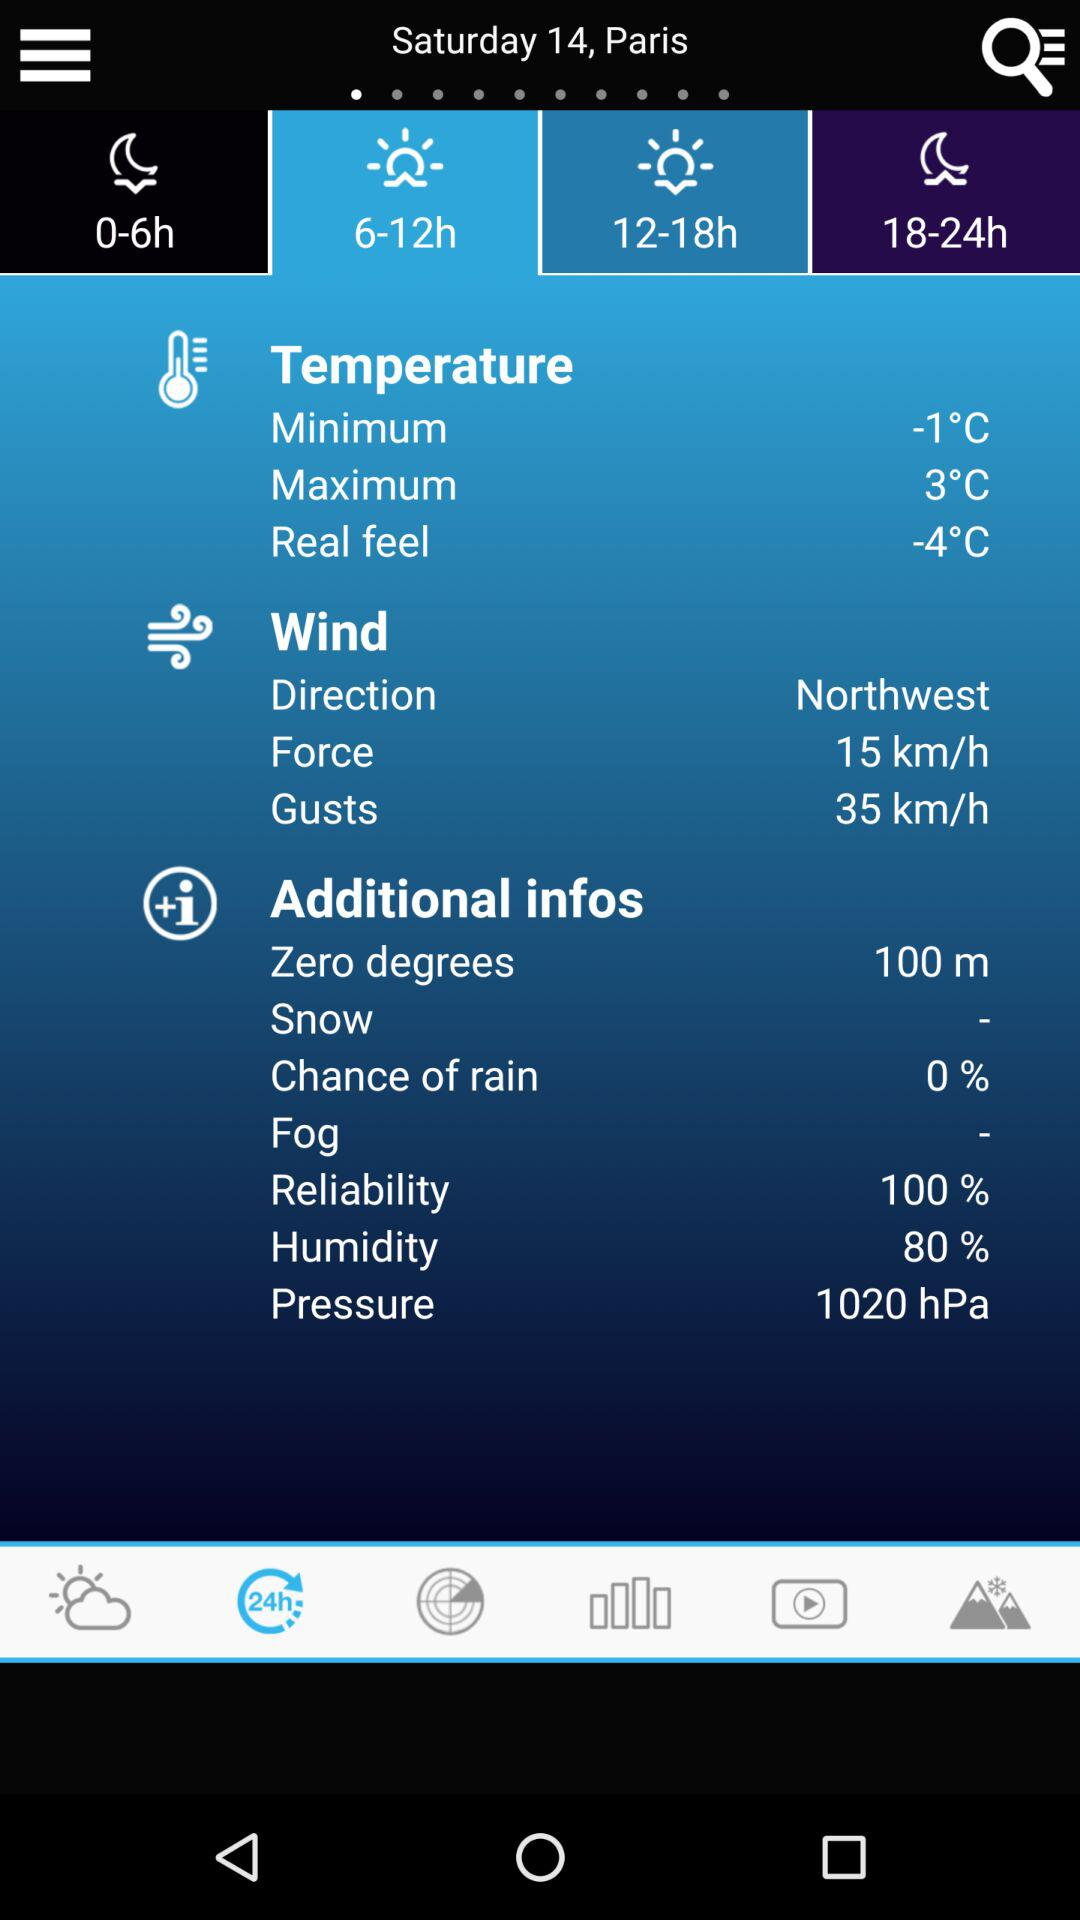What is the percentage of "chance of rain"? The percentage is 0. 